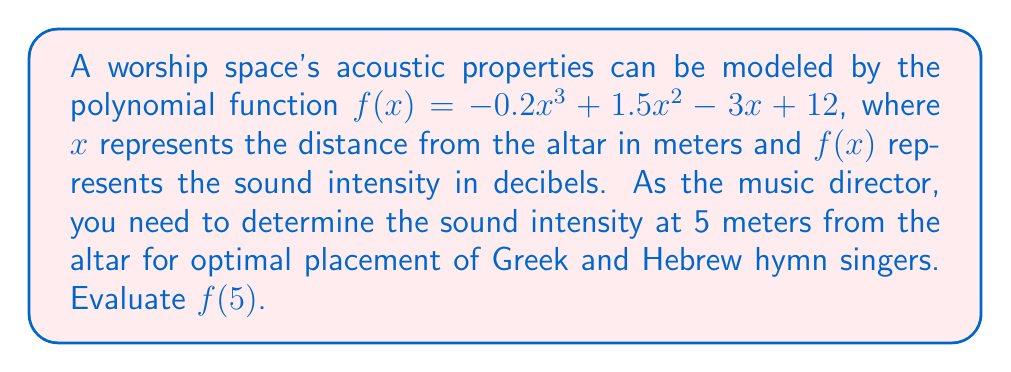Can you solve this math problem? To evaluate $f(5)$, we need to substitute $x=5$ into the given polynomial function:

$f(5) = -0.2(5)^3 + 1.5(5)^2 - 3(5) + 12$

Let's calculate each term:

1. $-0.2(5)^3 = -0.2 \cdot 125 = -25$
2. $1.5(5)^2 = 1.5 \cdot 25 = 37.5$
3. $-3(5) = -15$
4. $12$ remains as is

Now, we sum all these terms:

$f(5) = -25 + 37.5 - 15 + 12$

$f(5) = 9.5$

Therefore, the sound intensity at 5 meters from the altar is 9.5 decibels.
Answer: 9.5 decibels 